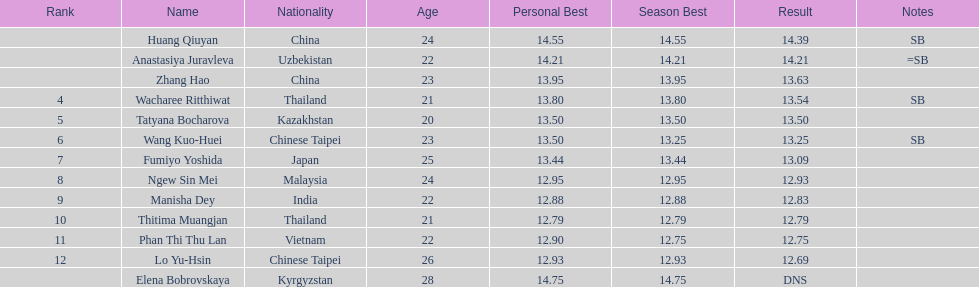How many competitors had less than 13.00 points? 6. 